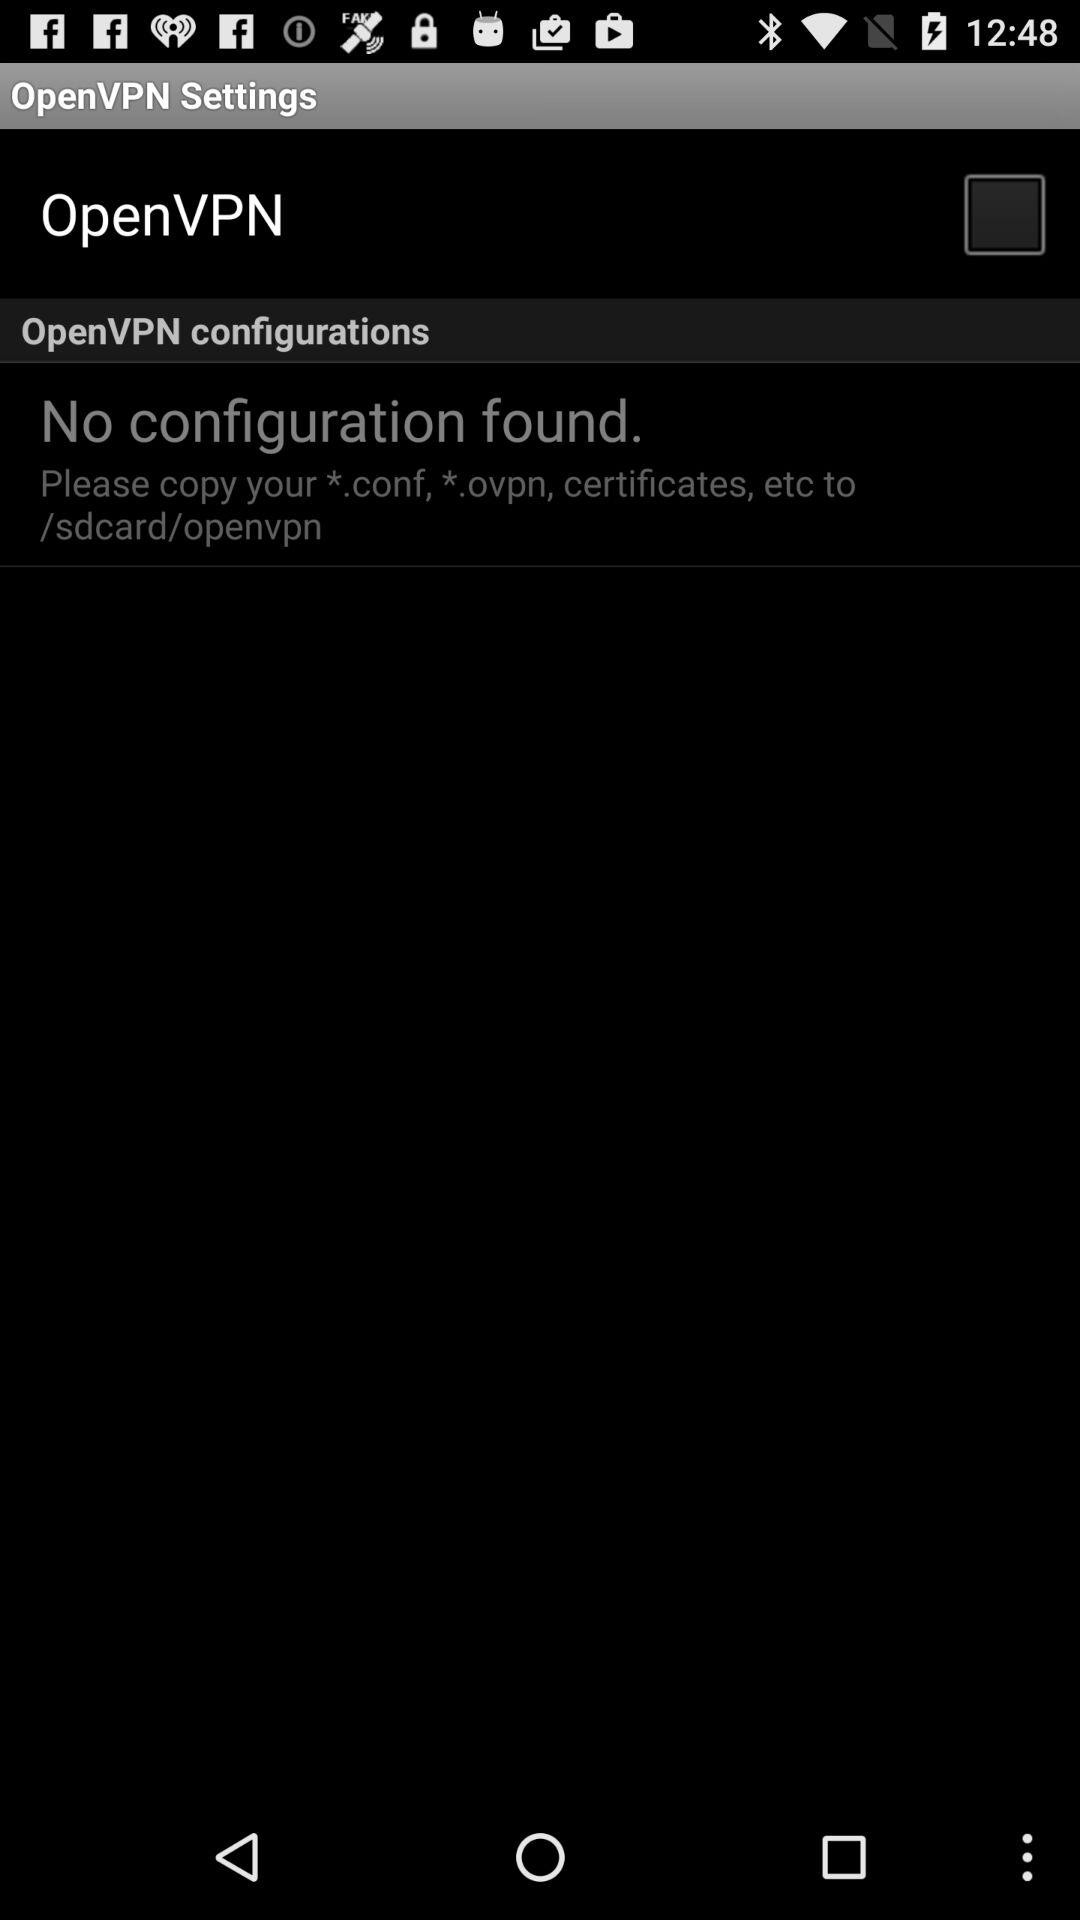What is the status of "OpenVPN"? The status is "off". 